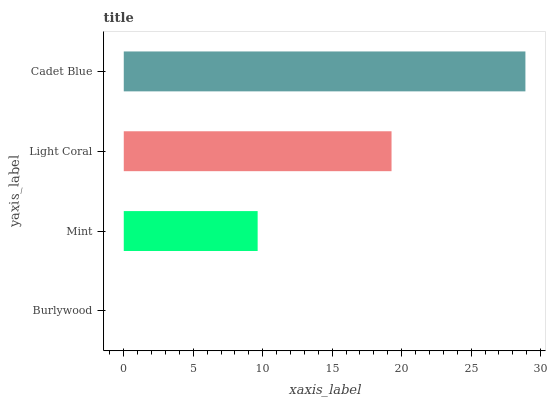Is Burlywood the minimum?
Answer yes or no. Yes. Is Cadet Blue the maximum?
Answer yes or no. Yes. Is Mint the minimum?
Answer yes or no. No. Is Mint the maximum?
Answer yes or no. No. Is Mint greater than Burlywood?
Answer yes or no. Yes. Is Burlywood less than Mint?
Answer yes or no. Yes. Is Burlywood greater than Mint?
Answer yes or no. No. Is Mint less than Burlywood?
Answer yes or no. No. Is Light Coral the high median?
Answer yes or no. Yes. Is Mint the low median?
Answer yes or no. Yes. Is Mint the high median?
Answer yes or no. No. Is Burlywood the low median?
Answer yes or no. No. 